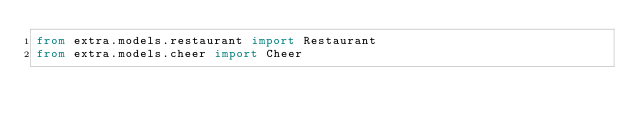Convert code to text. <code><loc_0><loc_0><loc_500><loc_500><_Python_>from extra.models.restaurant import Restaurant
from extra.models.cheer import Cheer
</code> 